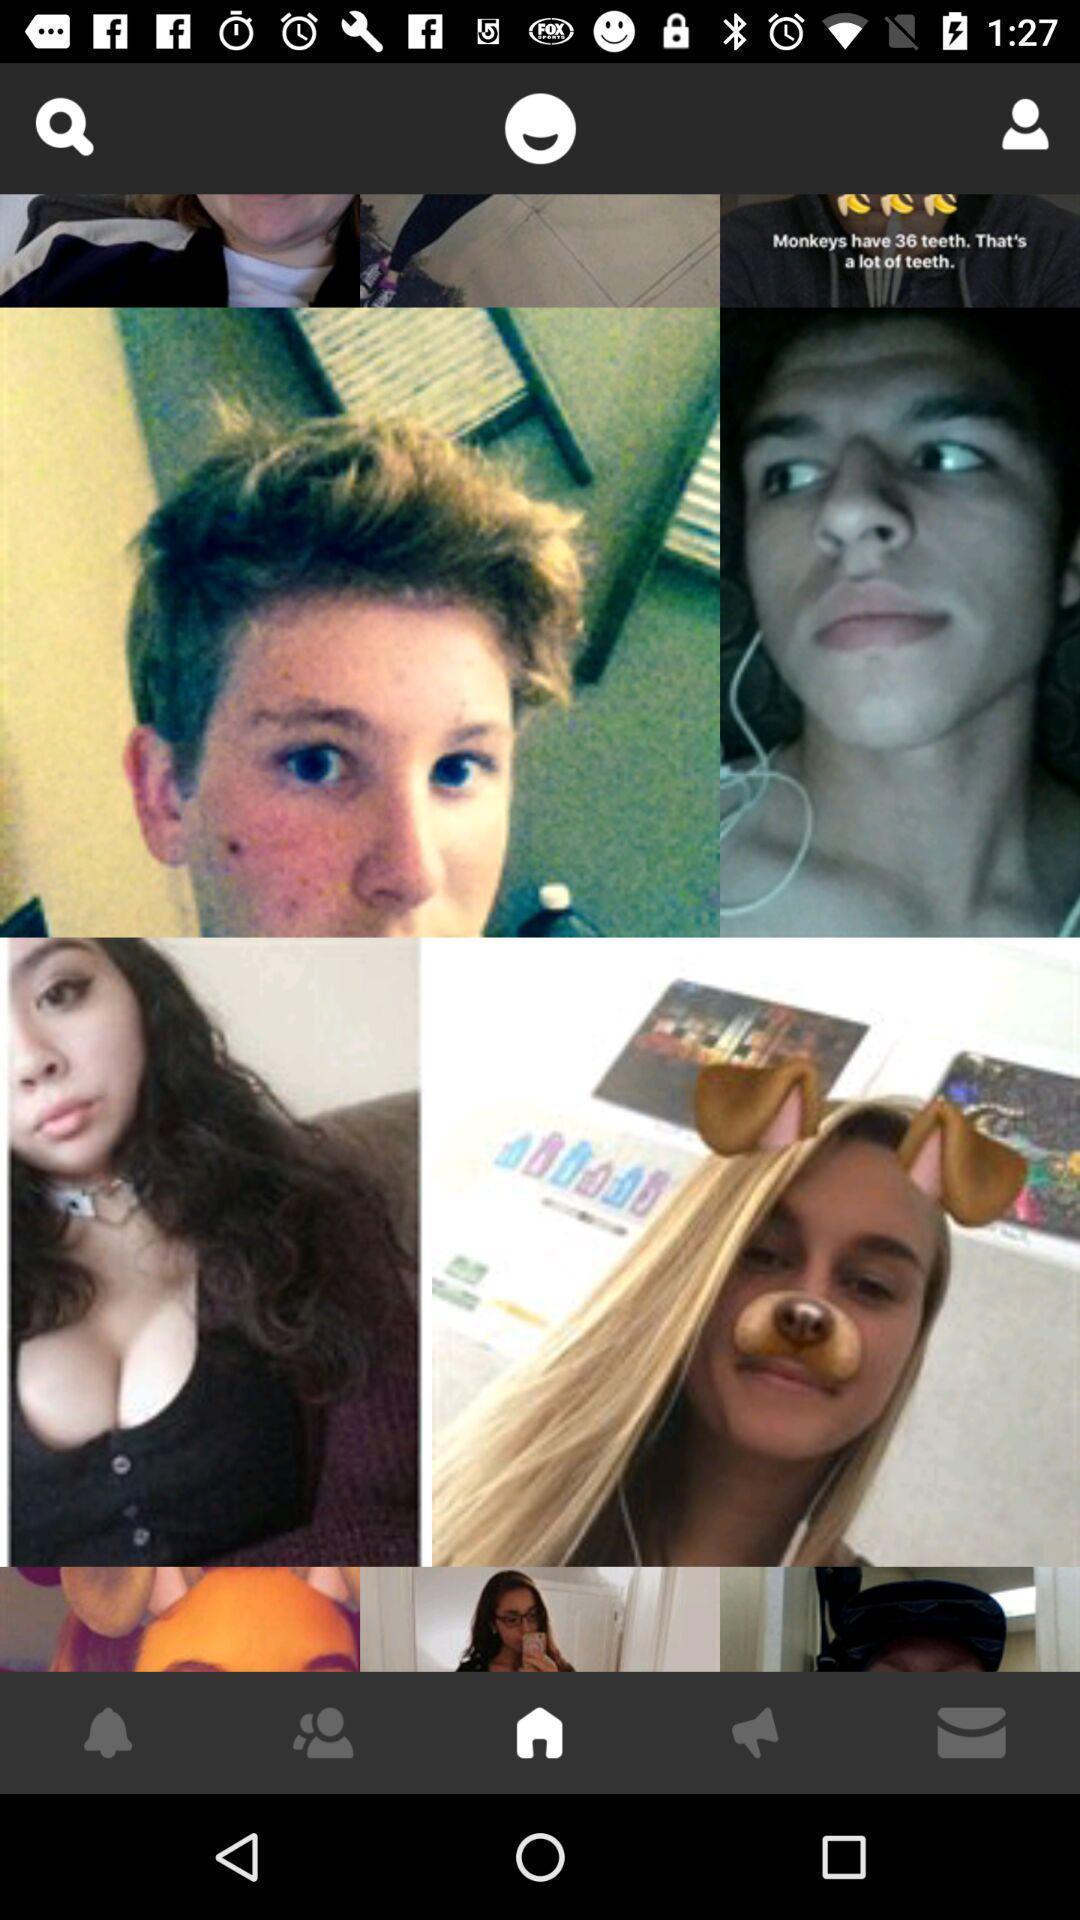Give me a summary of this screen capture. Page showing the images of different people. 